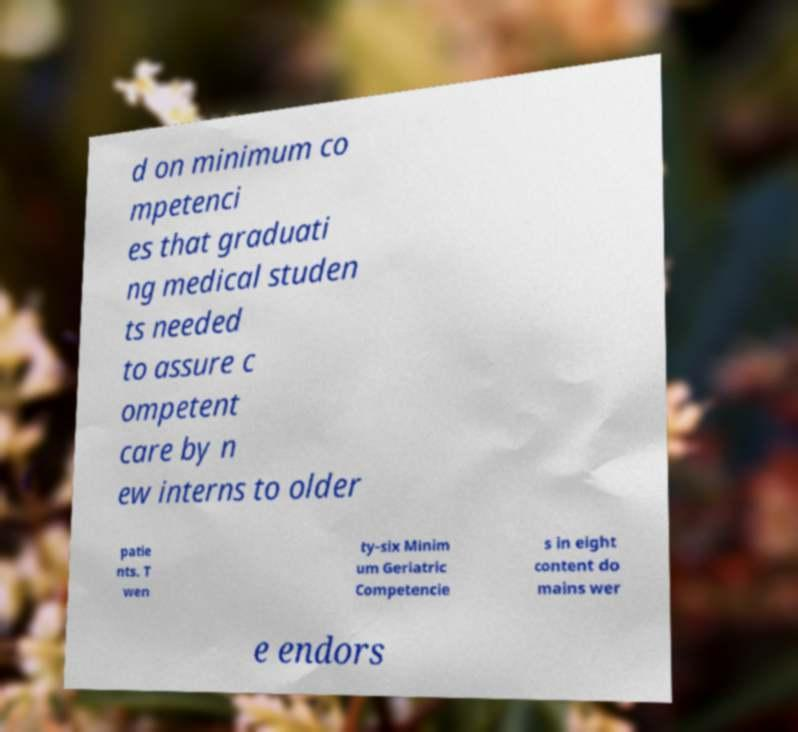Could you assist in decoding the text presented in this image and type it out clearly? d on minimum co mpetenci es that graduati ng medical studen ts needed to assure c ompetent care by n ew interns to older patie nts. T wen ty-six Minim um Geriatric Competencie s in eight content do mains wer e endors 